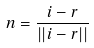Convert formula to latex. <formula><loc_0><loc_0><loc_500><loc_500>n = \frac { i - r } { | | i - r | | }</formula> 